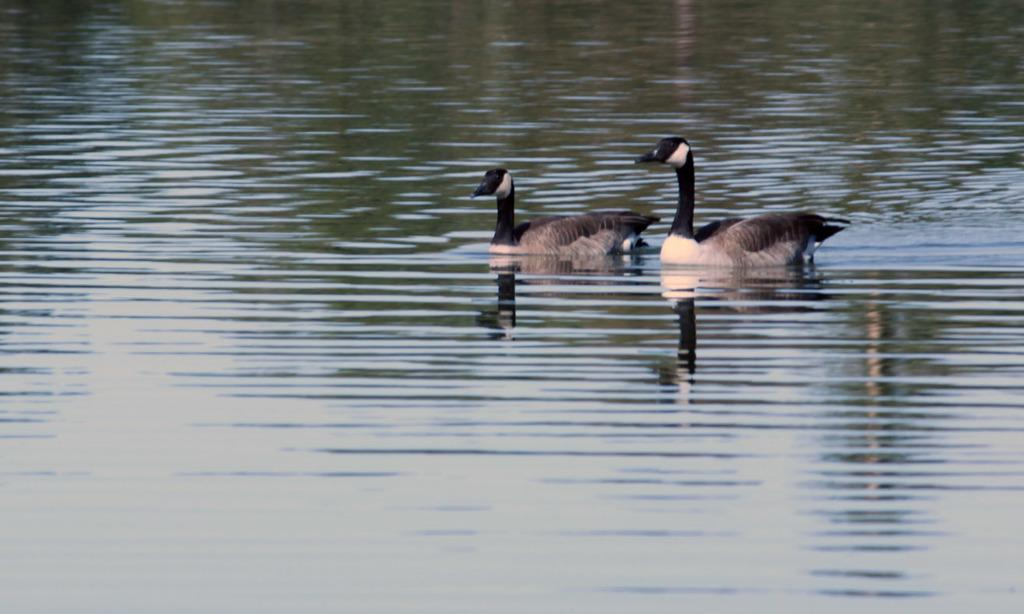What animals are present in the image? There are two ducks in the image. Where are the ducks located? The ducks are on the water. What type of dinosaurs can be seen swimming in the water with the ducks? There are no dinosaurs present in the image; it features two ducks on the water. What kind of test is being conducted on the ducks in the image? There is no test being conducted on the ducks in the image; they are simply on the water. 